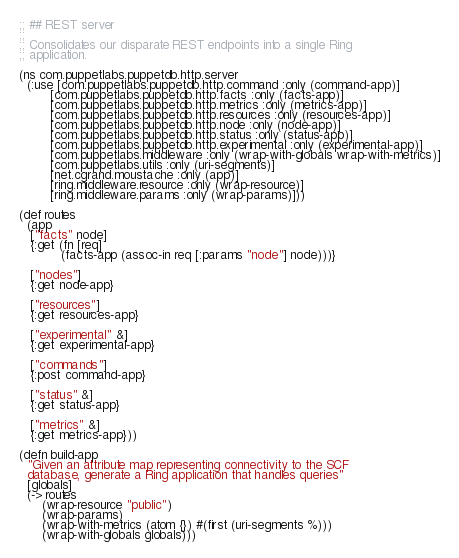<code> <loc_0><loc_0><loc_500><loc_500><_Clojure_>;; ## REST server
;;
;; Consolidates our disparate REST endpoints into a single Ring
;; application.

(ns com.puppetlabs.puppetdb.http.server
  (:use [com.puppetlabs.puppetdb.http.command :only (command-app)]
        [com.puppetlabs.puppetdb.http.facts :only (facts-app)]
        [com.puppetlabs.puppetdb.http.metrics :only (metrics-app)]
        [com.puppetlabs.puppetdb.http.resources :only (resources-app)]
        [com.puppetlabs.puppetdb.http.node :only (node-app)]
        [com.puppetlabs.puppetdb.http.status :only (status-app)]
        [com.puppetlabs.puppetdb.http.experimental :only (experimental-app)]
        [com.puppetlabs.middleware :only (wrap-with-globals wrap-with-metrics)]
        [com.puppetlabs.utils :only (uri-segments)]
        [net.cgrand.moustache :only (app)]
        [ring.middleware.resource :only (wrap-resource)]
        [ring.middleware.params :only (wrap-params)]))

(def routes
  (app
   ["facts" node]
   {:get (fn [req]
           (facts-app (assoc-in req [:params "node"] node)))}

   ["nodes"]
   {:get node-app}

   ["resources"]
   {:get resources-app}

   ["experimental" &]
   {:get experimental-app}

   ["commands"]
   {:post command-app}

   ["status" &]
   {:get status-app}

   ["metrics" &]
   {:get metrics-app}))

(defn build-app
  "Given an attribute map representing connectivity to the SCF
  database, generate a Ring application that handles queries"
  [globals]
  (-> routes
      (wrap-resource "public")
      (wrap-params)
      (wrap-with-metrics (atom {}) #(first (uri-segments %)))
      (wrap-with-globals globals)))
</code> 